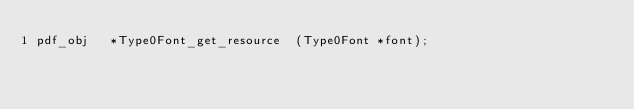<code> <loc_0><loc_0><loc_500><loc_500><_C_>pdf_obj   *Type0Font_get_resource  (Type0Font *font);
</code> 